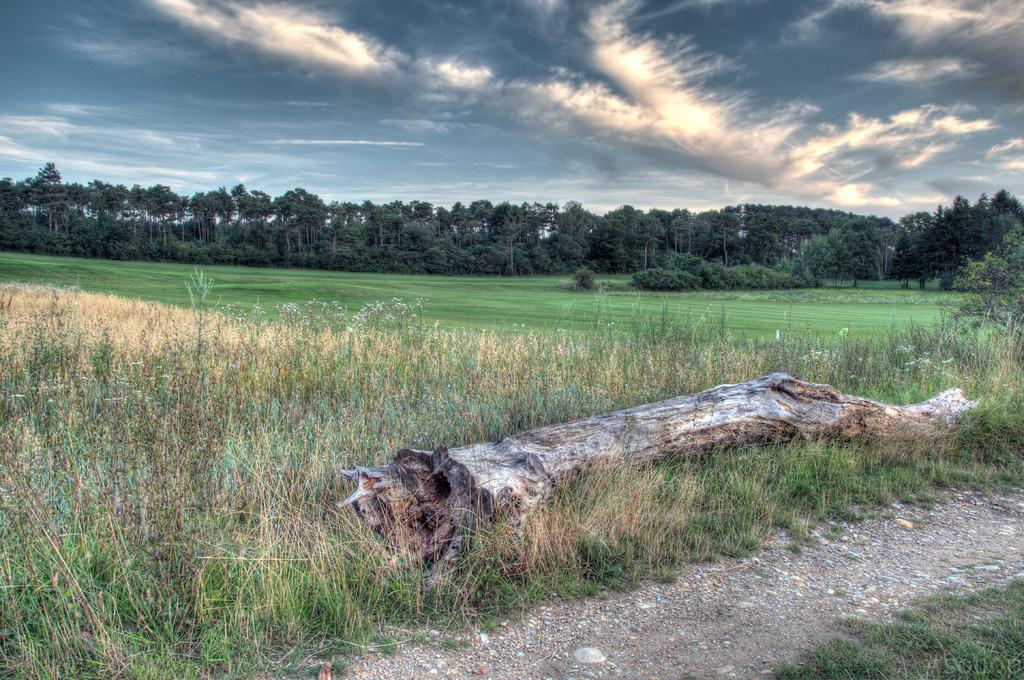What is located in the middle of the image? There is a wooden bark in the middle of the image. What can be seen in the background of the image? There are plants, trees, and clouds visible in the background of the image. What type of car can be seen driving through the wooden bark in the image? There is no car present in the image; it features a wooden bark with plants, trees, and clouds in the background. 